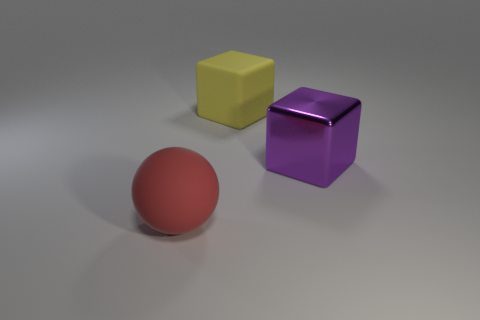Is there anything else that is the same material as the purple thing?
Keep it short and to the point. No. What number of big things are either yellow rubber objects or balls?
Offer a very short reply. 2. How many red rubber balls are there?
Ensure brevity in your answer.  1. Are there an equal number of large metal cubes behind the big metallic object and big matte objects that are behind the big red rubber thing?
Make the answer very short. No. There is a big metallic thing; are there any yellow matte objects to the left of it?
Offer a very short reply. Yes. What color is the large object that is on the left side of the large yellow matte thing?
Provide a succinct answer. Red. There is a thing to the left of the rubber thing that is to the right of the red thing; what is it made of?
Make the answer very short. Rubber. Is the number of purple things in front of the purple metal block less than the number of big purple cubes that are on the left side of the large yellow rubber thing?
Offer a very short reply. No. What number of blue objects are either spheres or big metallic cubes?
Give a very brief answer. 0. Are there the same number of purple metallic objects left of the matte cube and large cyan metallic blocks?
Give a very brief answer. Yes. 